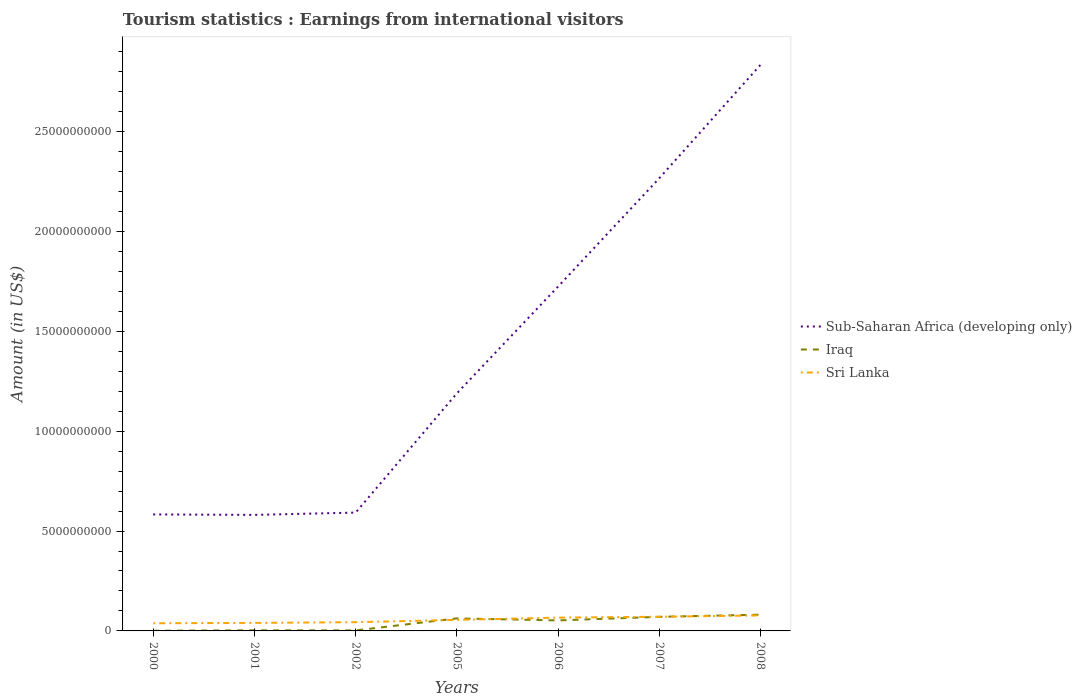Is the number of lines equal to the number of legend labels?
Your answer should be compact. Yes. Across all years, what is the maximum earnings from international visitors in Sri Lanka?
Your response must be concise. 3.83e+08. In which year was the earnings from international visitors in Sub-Saharan Africa (developing only) maximum?
Provide a short and direct response. 2001. What is the total earnings from international visitors in Sub-Saharan Africa (developing only) in the graph?
Ensure brevity in your answer.  -1.64e+1. What is the difference between the highest and the second highest earnings from international visitors in Sub-Saharan Africa (developing only)?
Make the answer very short. 2.25e+1. What is the difference between two consecutive major ticks on the Y-axis?
Your answer should be compact. 5.00e+09. Are the values on the major ticks of Y-axis written in scientific E-notation?
Provide a succinct answer. No. Does the graph contain grids?
Your answer should be compact. No. How many legend labels are there?
Your response must be concise. 3. How are the legend labels stacked?
Keep it short and to the point. Vertical. What is the title of the graph?
Give a very brief answer. Tourism statistics : Earnings from international visitors. Does "Bangladesh" appear as one of the legend labels in the graph?
Offer a terse response. No. What is the Amount (in US$) of Sub-Saharan Africa (developing only) in 2000?
Your answer should be very brief. 5.83e+09. What is the Amount (in US$) of Iraq in 2000?
Your answer should be very brief. 9.00e+06. What is the Amount (in US$) in Sri Lanka in 2000?
Make the answer very short. 3.83e+08. What is the Amount (in US$) of Sub-Saharan Africa (developing only) in 2001?
Make the answer very short. 5.81e+09. What is the Amount (in US$) of Iraq in 2001?
Your response must be concise. 3.10e+07. What is the Amount (in US$) of Sri Lanka in 2001?
Ensure brevity in your answer.  4.02e+08. What is the Amount (in US$) of Sub-Saharan Africa (developing only) in 2002?
Your answer should be very brief. 5.92e+09. What is the Amount (in US$) in Iraq in 2002?
Your answer should be compact. 2.60e+07. What is the Amount (in US$) in Sri Lanka in 2002?
Give a very brief answer. 4.38e+08. What is the Amount (in US$) in Sub-Saharan Africa (developing only) in 2005?
Provide a succinct answer. 1.19e+1. What is the Amount (in US$) in Iraq in 2005?
Give a very brief answer. 6.27e+08. What is the Amount (in US$) in Sri Lanka in 2005?
Your response must be concise. 5.52e+08. What is the Amount (in US$) in Sub-Saharan Africa (developing only) in 2006?
Give a very brief answer. 1.72e+1. What is the Amount (in US$) in Iraq in 2006?
Offer a terse response. 5.26e+08. What is the Amount (in US$) of Sri Lanka in 2006?
Keep it short and to the point. 6.66e+08. What is the Amount (in US$) of Sub-Saharan Africa (developing only) in 2007?
Your answer should be compact. 2.27e+1. What is the Amount (in US$) in Iraq in 2007?
Offer a very short reply. 7.05e+08. What is the Amount (in US$) of Sri Lanka in 2007?
Give a very brief answer. 7.09e+08. What is the Amount (in US$) of Sub-Saharan Africa (developing only) in 2008?
Give a very brief answer. 2.83e+1. What is the Amount (in US$) of Iraq in 2008?
Make the answer very short. 8.13e+08. What is the Amount (in US$) in Sri Lanka in 2008?
Your answer should be compact. 7.77e+08. Across all years, what is the maximum Amount (in US$) of Sub-Saharan Africa (developing only)?
Offer a very short reply. 2.83e+1. Across all years, what is the maximum Amount (in US$) in Iraq?
Your answer should be very brief. 8.13e+08. Across all years, what is the maximum Amount (in US$) of Sri Lanka?
Your response must be concise. 7.77e+08. Across all years, what is the minimum Amount (in US$) in Sub-Saharan Africa (developing only)?
Provide a short and direct response. 5.81e+09. Across all years, what is the minimum Amount (in US$) of Iraq?
Keep it short and to the point. 9.00e+06. Across all years, what is the minimum Amount (in US$) of Sri Lanka?
Keep it short and to the point. 3.83e+08. What is the total Amount (in US$) in Sub-Saharan Africa (developing only) in the graph?
Offer a very short reply. 9.77e+1. What is the total Amount (in US$) in Iraq in the graph?
Offer a terse response. 2.74e+09. What is the total Amount (in US$) of Sri Lanka in the graph?
Make the answer very short. 3.93e+09. What is the difference between the Amount (in US$) of Sub-Saharan Africa (developing only) in 2000 and that in 2001?
Your answer should be very brief. 2.30e+07. What is the difference between the Amount (in US$) of Iraq in 2000 and that in 2001?
Make the answer very short. -2.20e+07. What is the difference between the Amount (in US$) of Sri Lanka in 2000 and that in 2001?
Provide a succinct answer. -1.90e+07. What is the difference between the Amount (in US$) in Sub-Saharan Africa (developing only) in 2000 and that in 2002?
Make the answer very short. -9.17e+07. What is the difference between the Amount (in US$) in Iraq in 2000 and that in 2002?
Offer a very short reply. -1.70e+07. What is the difference between the Amount (in US$) in Sri Lanka in 2000 and that in 2002?
Provide a succinct answer. -5.50e+07. What is the difference between the Amount (in US$) of Sub-Saharan Africa (developing only) in 2000 and that in 2005?
Ensure brevity in your answer.  -6.06e+09. What is the difference between the Amount (in US$) in Iraq in 2000 and that in 2005?
Keep it short and to the point. -6.18e+08. What is the difference between the Amount (in US$) of Sri Lanka in 2000 and that in 2005?
Provide a succinct answer. -1.69e+08. What is the difference between the Amount (in US$) of Sub-Saharan Africa (developing only) in 2000 and that in 2006?
Keep it short and to the point. -1.14e+1. What is the difference between the Amount (in US$) in Iraq in 2000 and that in 2006?
Make the answer very short. -5.17e+08. What is the difference between the Amount (in US$) of Sri Lanka in 2000 and that in 2006?
Your response must be concise. -2.83e+08. What is the difference between the Amount (in US$) in Sub-Saharan Africa (developing only) in 2000 and that in 2007?
Your response must be concise. -1.68e+1. What is the difference between the Amount (in US$) of Iraq in 2000 and that in 2007?
Your response must be concise. -6.96e+08. What is the difference between the Amount (in US$) in Sri Lanka in 2000 and that in 2007?
Provide a succinct answer. -3.26e+08. What is the difference between the Amount (in US$) in Sub-Saharan Africa (developing only) in 2000 and that in 2008?
Offer a very short reply. -2.25e+1. What is the difference between the Amount (in US$) in Iraq in 2000 and that in 2008?
Provide a short and direct response. -8.04e+08. What is the difference between the Amount (in US$) in Sri Lanka in 2000 and that in 2008?
Your response must be concise. -3.94e+08. What is the difference between the Amount (in US$) in Sub-Saharan Africa (developing only) in 2001 and that in 2002?
Keep it short and to the point. -1.15e+08. What is the difference between the Amount (in US$) of Iraq in 2001 and that in 2002?
Give a very brief answer. 5.00e+06. What is the difference between the Amount (in US$) in Sri Lanka in 2001 and that in 2002?
Offer a terse response. -3.60e+07. What is the difference between the Amount (in US$) of Sub-Saharan Africa (developing only) in 2001 and that in 2005?
Offer a terse response. -6.08e+09. What is the difference between the Amount (in US$) of Iraq in 2001 and that in 2005?
Keep it short and to the point. -5.96e+08. What is the difference between the Amount (in US$) of Sri Lanka in 2001 and that in 2005?
Your answer should be compact. -1.50e+08. What is the difference between the Amount (in US$) in Sub-Saharan Africa (developing only) in 2001 and that in 2006?
Provide a succinct answer. -1.14e+1. What is the difference between the Amount (in US$) in Iraq in 2001 and that in 2006?
Your response must be concise. -4.95e+08. What is the difference between the Amount (in US$) in Sri Lanka in 2001 and that in 2006?
Keep it short and to the point. -2.64e+08. What is the difference between the Amount (in US$) of Sub-Saharan Africa (developing only) in 2001 and that in 2007?
Provide a succinct answer. -1.68e+1. What is the difference between the Amount (in US$) in Iraq in 2001 and that in 2007?
Your answer should be very brief. -6.74e+08. What is the difference between the Amount (in US$) in Sri Lanka in 2001 and that in 2007?
Your answer should be compact. -3.07e+08. What is the difference between the Amount (in US$) in Sub-Saharan Africa (developing only) in 2001 and that in 2008?
Offer a very short reply. -2.25e+1. What is the difference between the Amount (in US$) in Iraq in 2001 and that in 2008?
Offer a terse response. -7.82e+08. What is the difference between the Amount (in US$) of Sri Lanka in 2001 and that in 2008?
Your answer should be compact. -3.75e+08. What is the difference between the Amount (in US$) in Sub-Saharan Africa (developing only) in 2002 and that in 2005?
Your answer should be compact. -5.97e+09. What is the difference between the Amount (in US$) in Iraq in 2002 and that in 2005?
Offer a very short reply. -6.01e+08. What is the difference between the Amount (in US$) of Sri Lanka in 2002 and that in 2005?
Provide a short and direct response. -1.14e+08. What is the difference between the Amount (in US$) of Sub-Saharan Africa (developing only) in 2002 and that in 2006?
Offer a terse response. -1.13e+1. What is the difference between the Amount (in US$) of Iraq in 2002 and that in 2006?
Give a very brief answer. -5.00e+08. What is the difference between the Amount (in US$) of Sri Lanka in 2002 and that in 2006?
Your response must be concise. -2.28e+08. What is the difference between the Amount (in US$) of Sub-Saharan Africa (developing only) in 2002 and that in 2007?
Provide a succinct answer. -1.67e+1. What is the difference between the Amount (in US$) of Iraq in 2002 and that in 2007?
Make the answer very short. -6.79e+08. What is the difference between the Amount (in US$) in Sri Lanka in 2002 and that in 2007?
Your answer should be compact. -2.71e+08. What is the difference between the Amount (in US$) of Sub-Saharan Africa (developing only) in 2002 and that in 2008?
Your answer should be compact. -2.24e+1. What is the difference between the Amount (in US$) in Iraq in 2002 and that in 2008?
Your answer should be very brief. -7.87e+08. What is the difference between the Amount (in US$) of Sri Lanka in 2002 and that in 2008?
Make the answer very short. -3.39e+08. What is the difference between the Amount (in US$) in Sub-Saharan Africa (developing only) in 2005 and that in 2006?
Your answer should be very brief. -5.34e+09. What is the difference between the Amount (in US$) of Iraq in 2005 and that in 2006?
Offer a terse response. 1.01e+08. What is the difference between the Amount (in US$) in Sri Lanka in 2005 and that in 2006?
Your response must be concise. -1.14e+08. What is the difference between the Amount (in US$) in Sub-Saharan Africa (developing only) in 2005 and that in 2007?
Offer a terse response. -1.08e+1. What is the difference between the Amount (in US$) in Iraq in 2005 and that in 2007?
Give a very brief answer. -7.80e+07. What is the difference between the Amount (in US$) of Sri Lanka in 2005 and that in 2007?
Your answer should be compact. -1.57e+08. What is the difference between the Amount (in US$) of Sub-Saharan Africa (developing only) in 2005 and that in 2008?
Offer a terse response. -1.64e+1. What is the difference between the Amount (in US$) in Iraq in 2005 and that in 2008?
Provide a succinct answer. -1.86e+08. What is the difference between the Amount (in US$) in Sri Lanka in 2005 and that in 2008?
Your answer should be very brief. -2.25e+08. What is the difference between the Amount (in US$) in Sub-Saharan Africa (developing only) in 2006 and that in 2007?
Offer a terse response. -5.42e+09. What is the difference between the Amount (in US$) of Iraq in 2006 and that in 2007?
Give a very brief answer. -1.79e+08. What is the difference between the Amount (in US$) of Sri Lanka in 2006 and that in 2007?
Give a very brief answer. -4.30e+07. What is the difference between the Amount (in US$) of Sub-Saharan Africa (developing only) in 2006 and that in 2008?
Offer a very short reply. -1.11e+1. What is the difference between the Amount (in US$) of Iraq in 2006 and that in 2008?
Provide a short and direct response. -2.87e+08. What is the difference between the Amount (in US$) of Sri Lanka in 2006 and that in 2008?
Keep it short and to the point. -1.11e+08. What is the difference between the Amount (in US$) in Sub-Saharan Africa (developing only) in 2007 and that in 2008?
Offer a very short reply. -5.68e+09. What is the difference between the Amount (in US$) of Iraq in 2007 and that in 2008?
Make the answer very short. -1.08e+08. What is the difference between the Amount (in US$) of Sri Lanka in 2007 and that in 2008?
Provide a succinct answer. -6.80e+07. What is the difference between the Amount (in US$) of Sub-Saharan Africa (developing only) in 2000 and the Amount (in US$) of Iraq in 2001?
Give a very brief answer. 5.80e+09. What is the difference between the Amount (in US$) in Sub-Saharan Africa (developing only) in 2000 and the Amount (in US$) in Sri Lanka in 2001?
Keep it short and to the point. 5.43e+09. What is the difference between the Amount (in US$) in Iraq in 2000 and the Amount (in US$) in Sri Lanka in 2001?
Give a very brief answer. -3.93e+08. What is the difference between the Amount (in US$) of Sub-Saharan Africa (developing only) in 2000 and the Amount (in US$) of Iraq in 2002?
Offer a very short reply. 5.81e+09. What is the difference between the Amount (in US$) in Sub-Saharan Africa (developing only) in 2000 and the Amount (in US$) in Sri Lanka in 2002?
Your answer should be very brief. 5.39e+09. What is the difference between the Amount (in US$) of Iraq in 2000 and the Amount (in US$) of Sri Lanka in 2002?
Ensure brevity in your answer.  -4.29e+08. What is the difference between the Amount (in US$) of Sub-Saharan Africa (developing only) in 2000 and the Amount (in US$) of Iraq in 2005?
Provide a short and direct response. 5.20e+09. What is the difference between the Amount (in US$) of Sub-Saharan Africa (developing only) in 2000 and the Amount (in US$) of Sri Lanka in 2005?
Your response must be concise. 5.28e+09. What is the difference between the Amount (in US$) of Iraq in 2000 and the Amount (in US$) of Sri Lanka in 2005?
Keep it short and to the point. -5.43e+08. What is the difference between the Amount (in US$) of Sub-Saharan Africa (developing only) in 2000 and the Amount (in US$) of Iraq in 2006?
Make the answer very short. 5.31e+09. What is the difference between the Amount (in US$) of Sub-Saharan Africa (developing only) in 2000 and the Amount (in US$) of Sri Lanka in 2006?
Your answer should be compact. 5.17e+09. What is the difference between the Amount (in US$) of Iraq in 2000 and the Amount (in US$) of Sri Lanka in 2006?
Offer a terse response. -6.57e+08. What is the difference between the Amount (in US$) of Sub-Saharan Africa (developing only) in 2000 and the Amount (in US$) of Iraq in 2007?
Offer a terse response. 5.13e+09. What is the difference between the Amount (in US$) in Sub-Saharan Africa (developing only) in 2000 and the Amount (in US$) in Sri Lanka in 2007?
Ensure brevity in your answer.  5.12e+09. What is the difference between the Amount (in US$) of Iraq in 2000 and the Amount (in US$) of Sri Lanka in 2007?
Make the answer very short. -7.00e+08. What is the difference between the Amount (in US$) of Sub-Saharan Africa (developing only) in 2000 and the Amount (in US$) of Iraq in 2008?
Keep it short and to the point. 5.02e+09. What is the difference between the Amount (in US$) of Sub-Saharan Africa (developing only) in 2000 and the Amount (in US$) of Sri Lanka in 2008?
Your answer should be compact. 5.05e+09. What is the difference between the Amount (in US$) in Iraq in 2000 and the Amount (in US$) in Sri Lanka in 2008?
Provide a succinct answer. -7.68e+08. What is the difference between the Amount (in US$) in Sub-Saharan Africa (developing only) in 2001 and the Amount (in US$) in Iraq in 2002?
Provide a succinct answer. 5.78e+09. What is the difference between the Amount (in US$) in Sub-Saharan Africa (developing only) in 2001 and the Amount (in US$) in Sri Lanka in 2002?
Offer a very short reply. 5.37e+09. What is the difference between the Amount (in US$) of Iraq in 2001 and the Amount (in US$) of Sri Lanka in 2002?
Ensure brevity in your answer.  -4.07e+08. What is the difference between the Amount (in US$) of Sub-Saharan Africa (developing only) in 2001 and the Amount (in US$) of Iraq in 2005?
Your answer should be very brief. 5.18e+09. What is the difference between the Amount (in US$) of Sub-Saharan Africa (developing only) in 2001 and the Amount (in US$) of Sri Lanka in 2005?
Keep it short and to the point. 5.26e+09. What is the difference between the Amount (in US$) of Iraq in 2001 and the Amount (in US$) of Sri Lanka in 2005?
Your answer should be very brief. -5.21e+08. What is the difference between the Amount (in US$) of Sub-Saharan Africa (developing only) in 2001 and the Amount (in US$) of Iraq in 2006?
Offer a terse response. 5.28e+09. What is the difference between the Amount (in US$) of Sub-Saharan Africa (developing only) in 2001 and the Amount (in US$) of Sri Lanka in 2006?
Give a very brief answer. 5.14e+09. What is the difference between the Amount (in US$) of Iraq in 2001 and the Amount (in US$) of Sri Lanka in 2006?
Offer a terse response. -6.35e+08. What is the difference between the Amount (in US$) of Sub-Saharan Africa (developing only) in 2001 and the Amount (in US$) of Iraq in 2007?
Give a very brief answer. 5.10e+09. What is the difference between the Amount (in US$) of Sub-Saharan Africa (developing only) in 2001 and the Amount (in US$) of Sri Lanka in 2007?
Ensure brevity in your answer.  5.10e+09. What is the difference between the Amount (in US$) of Iraq in 2001 and the Amount (in US$) of Sri Lanka in 2007?
Give a very brief answer. -6.78e+08. What is the difference between the Amount (in US$) in Sub-Saharan Africa (developing only) in 2001 and the Amount (in US$) in Iraq in 2008?
Your response must be concise. 5.00e+09. What is the difference between the Amount (in US$) of Sub-Saharan Africa (developing only) in 2001 and the Amount (in US$) of Sri Lanka in 2008?
Your answer should be very brief. 5.03e+09. What is the difference between the Amount (in US$) of Iraq in 2001 and the Amount (in US$) of Sri Lanka in 2008?
Your answer should be compact. -7.46e+08. What is the difference between the Amount (in US$) in Sub-Saharan Africa (developing only) in 2002 and the Amount (in US$) in Iraq in 2005?
Your response must be concise. 5.30e+09. What is the difference between the Amount (in US$) of Sub-Saharan Africa (developing only) in 2002 and the Amount (in US$) of Sri Lanka in 2005?
Keep it short and to the point. 5.37e+09. What is the difference between the Amount (in US$) in Iraq in 2002 and the Amount (in US$) in Sri Lanka in 2005?
Your answer should be very brief. -5.26e+08. What is the difference between the Amount (in US$) of Sub-Saharan Africa (developing only) in 2002 and the Amount (in US$) of Iraq in 2006?
Ensure brevity in your answer.  5.40e+09. What is the difference between the Amount (in US$) in Sub-Saharan Africa (developing only) in 2002 and the Amount (in US$) in Sri Lanka in 2006?
Your answer should be compact. 5.26e+09. What is the difference between the Amount (in US$) in Iraq in 2002 and the Amount (in US$) in Sri Lanka in 2006?
Ensure brevity in your answer.  -6.40e+08. What is the difference between the Amount (in US$) of Sub-Saharan Africa (developing only) in 2002 and the Amount (in US$) of Iraq in 2007?
Make the answer very short. 5.22e+09. What is the difference between the Amount (in US$) in Sub-Saharan Africa (developing only) in 2002 and the Amount (in US$) in Sri Lanka in 2007?
Offer a terse response. 5.21e+09. What is the difference between the Amount (in US$) in Iraq in 2002 and the Amount (in US$) in Sri Lanka in 2007?
Provide a succinct answer. -6.83e+08. What is the difference between the Amount (in US$) of Sub-Saharan Africa (developing only) in 2002 and the Amount (in US$) of Iraq in 2008?
Give a very brief answer. 5.11e+09. What is the difference between the Amount (in US$) in Sub-Saharan Africa (developing only) in 2002 and the Amount (in US$) in Sri Lanka in 2008?
Provide a short and direct response. 5.15e+09. What is the difference between the Amount (in US$) in Iraq in 2002 and the Amount (in US$) in Sri Lanka in 2008?
Your answer should be compact. -7.51e+08. What is the difference between the Amount (in US$) in Sub-Saharan Africa (developing only) in 2005 and the Amount (in US$) in Iraq in 2006?
Provide a short and direct response. 1.14e+1. What is the difference between the Amount (in US$) of Sub-Saharan Africa (developing only) in 2005 and the Amount (in US$) of Sri Lanka in 2006?
Keep it short and to the point. 1.12e+1. What is the difference between the Amount (in US$) of Iraq in 2005 and the Amount (in US$) of Sri Lanka in 2006?
Provide a succinct answer. -3.90e+07. What is the difference between the Amount (in US$) in Sub-Saharan Africa (developing only) in 2005 and the Amount (in US$) in Iraq in 2007?
Keep it short and to the point. 1.12e+1. What is the difference between the Amount (in US$) in Sub-Saharan Africa (developing only) in 2005 and the Amount (in US$) in Sri Lanka in 2007?
Your answer should be very brief. 1.12e+1. What is the difference between the Amount (in US$) in Iraq in 2005 and the Amount (in US$) in Sri Lanka in 2007?
Give a very brief answer. -8.20e+07. What is the difference between the Amount (in US$) of Sub-Saharan Africa (developing only) in 2005 and the Amount (in US$) of Iraq in 2008?
Offer a terse response. 1.11e+1. What is the difference between the Amount (in US$) in Sub-Saharan Africa (developing only) in 2005 and the Amount (in US$) in Sri Lanka in 2008?
Keep it short and to the point. 1.11e+1. What is the difference between the Amount (in US$) of Iraq in 2005 and the Amount (in US$) of Sri Lanka in 2008?
Your answer should be very brief. -1.50e+08. What is the difference between the Amount (in US$) in Sub-Saharan Africa (developing only) in 2006 and the Amount (in US$) in Iraq in 2007?
Offer a terse response. 1.65e+1. What is the difference between the Amount (in US$) of Sub-Saharan Africa (developing only) in 2006 and the Amount (in US$) of Sri Lanka in 2007?
Offer a very short reply. 1.65e+1. What is the difference between the Amount (in US$) of Iraq in 2006 and the Amount (in US$) of Sri Lanka in 2007?
Keep it short and to the point. -1.83e+08. What is the difference between the Amount (in US$) of Sub-Saharan Africa (developing only) in 2006 and the Amount (in US$) of Iraq in 2008?
Offer a very short reply. 1.64e+1. What is the difference between the Amount (in US$) of Sub-Saharan Africa (developing only) in 2006 and the Amount (in US$) of Sri Lanka in 2008?
Your answer should be compact. 1.65e+1. What is the difference between the Amount (in US$) of Iraq in 2006 and the Amount (in US$) of Sri Lanka in 2008?
Ensure brevity in your answer.  -2.51e+08. What is the difference between the Amount (in US$) of Sub-Saharan Africa (developing only) in 2007 and the Amount (in US$) of Iraq in 2008?
Your response must be concise. 2.18e+1. What is the difference between the Amount (in US$) in Sub-Saharan Africa (developing only) in 2007 and the Amount (in US$) in Sri Lanka in 2008?
Your response must be concise. 2.19e+1. What is the difference between the Amount (in US$) in Iraq in 2007 and the Amount (in US$) in Sri Lanka in 2008?
Your answer should be compact. -7.20e+07. What is the average Amount (in US$) in Sub-Saharan Africa (developing only) per year?
Your answer should be very brief. 1.40e+1. What is the average Amount (in US$) in Iraq per year?
Keep it short and to the point. 3.91e+08. What is the average Amount (in US$) in Sri Lanka per year?
Your answer should be very brief. 5.61e+08. In the year 2000, what is the difference between the Amount (in US$) of Sub-Saharan Africa (developing only) and Amount (in US$) of Iraq?
Make the answer very short. 5.82e+09. In the year 2000, what is the difference between the Amount (in US$) in Sub-Saharan Africa (developing only) and Amount (in US$) in Sri Lanka?
Make the answer very short. 5.45e+09. In the year 2000, what is the difference between the Amount (in US$) in Iraq and Amount (in US$) in Sri Lanka?
Keep it short and to the point. -3.74e+08. In the year 2001, what is the difference between the Amount (in US$) of Sub-Saharan Africa (developing only) and Amount (in US$) of Iraq?
Your response must be concise. 5.78e+09. In the year 2001, what is the difference between the Amount (in US$) of Sub-Saharan Africa (developing only) and Amount (in US$) of Sri Lanka?
Your answer should be compact. 5.41e+09. In the year 2001, what is the difference between the Amount (in US$) of Iraq and Amount (in US$) of Sri Lanka?
Make the answer very short. -3.71e+08. In the year 2002, what is the difference between the Amount (in US$) of Sub-Saharan Africa (developing only) and Amount (in US$) of Iraq?
Your answer should be very brief. 5.90e+09. In the year 2002, what is the difference between the Amount (in US$) of Sub-Saharan Africa (developing only) and Amount (in US$) of Sri Lanka?
Your answer should be very brief. 5.48e+09. In the year 2002, what is the difference between the Amount (in US$) in Iraq and Amount (in US$) in Sri Lanka?
Provide a succinct answer. -4.12e+08. In the year 2005, what is the difference between the Amount (in US$) of Sub-Saharan Africa (developing only) and Amount (in US$) of Iraq?
Give a very brief answer. 1.13e+1. In the year 2005, what is the difference between the Amount (in US$) of Sub-Saharan Africa (developing only) and Amount (in US$) of Sri Lanka?
Give a very brief answer. 1.13e+1. In the year 2005, what is the difference between the Amount (in US$) in Iraq and Amount (in US$) in Sri Lanka?
Ensure brevity in your answer.  7.50e+07. In the year 2006, what is the difference between the Amount (in US$) of Sub-Saharan Africa (developing only) and Amount (in US$) of Iraq?
Keep it short and to the point. 1.67e+1. In the year 2006, what is the difference between the Amount (in US$) in Sub-Saharan Africa (developing only) and Amount (in US$) in Sri Lanka?
Provide a short and direct response. 1.66e+1. In the year 2006, what is the difference between the Amount (in US$) in Iraq and Amount (in US$) in Sri Lanka?
Offer a terse response. -1.40e+08. In the year 2007, what is the difference between the Amount (in US$) of Sub-Saharan Africa (developing only) and Amount (in US$) of Iraq?
Your answer should be very brief. 2.20e+1. In the year 2007, what is the difference between the Amount (in US$) in Sub-Saharan Africa (developing only) and Amount (in US$) in Sri Lanka?
Ensure brevity in your answer.  2.19e+1. In the year 2007, what is the difference between the Amount (in US$) of Iraq and Amount (in US$) of Sri Lanka?
Make the answer very short. -4.00e+06. In the year 2008, what is the difference between the Amount (in US$) of Sub-Saharan Africa (developing only) and Amount (in US$) of Iraq?
Your answer should be very brief. 2.75e+1. In the year 2008, what is the difference between the Amount (in US$) in Sub-Saharan Africa (developing only) and Amount (in US$) in Sri Lanka?
Your answer should be very brief. 2.76e+1. In the year 2008, what is the difference between the Amount (in US$) of Iraq and Amount (in US$) of Sri Lanka?
Keep it short and to the point. 3.60e+07. What is the ratio of the Amount (in US$) in Sub-Saharan Africa (developing only) in 2000 to that in 2001?
Make the answer very short. 1. What is the ratio of the Amount (in US$) in Iraq in 2000 to that in 2001?
Offer a terse response. 0.29. What is the ratio of the Amount (in US$) of Sri Lanka in 2000 to that in 2001?
Provide a succinct answer. 0.95. What is the ratio of the Amount (in US$) of Sub-Saharan Africa (developing only) in 2000 to that in 2002?
Your answer should be compact. 0.98. What is the ratio of the Amount (in US$) of Iraq in 2000 to that in 2002?
Give a very brief answer. 0.35. What is the ratio of the Amount (in US$) in Sri Lanka in 2000 to that in 2002?
Provide a short and direct response. 0.87. What is the ratio of the Amount (in US$) of Sub-Saharan Africa (developing only) in 2000 to that in 2005?
Give a very brief answer. 0.49. What is the ratio of the Amount (in US$) in Iraq in 2000 to that in 2005?
Offer a terse response. 0.01. What is the ratio of the Amount (in US$) in Sri Lanka in 2000 to that in 2005?
Make the answer very short. 0.69. What is the ratio of the Amount (in US$) in Sub-Saharan Africa (developing only) in 2000 to that in 2006?
Your answer should be very brief. 0.34. What is the ratio of the Amount (in US$) in Iraq in 2000 to that in 2006?
Your answer should be compact. 0.02. What is the ratio of the Amount (in US$) of Sri Lanka in 2000 to that in 2006?
Provide a short and direct response. 0.58. What is the ratio of the Amount (in US$) of Sub-Saharan Africa (developing only) in 2000 to that in 2007?
Ensure brevity in your answer.  0.26. What is the ratio of the Amount (in US$) of Iraq in 2000 to that in 2007?
Keep it short and to the point. 0.01. What is the ratio of the Amount (in US$) in Sri Lanka in 2000 to that in 2007?
Your answer should be very brief. 0.54. What is the ratio of the Amount (in US$) of Sub-Saharan Africa (developing only) in 2000 to that in 2008?
Your answer should be compact. 0.21. What is the ratio of the Amount (in US$) of Iraq in 2000 to that in 2008?
Keep it short and to the point. 0.01. What is the ratio of the Amount (in US$) of Sri Lanka in 2000 to that in 2008?
Give a very brief answer. 0.49. What is the ratio of the Amount (in US$) of Sub-Saharan Africa (developing only) in 2001 to that in 2002?
Keep it short and to the point. 0.98. What is the ratio of the Amount (in US$) in Iraq in 2001 to that in 2002?
Provide a succinct answer. 1.19. What is the ratio of the Amount (in US$) in Sri Lanka in 2001 to that in 2002?
Offer a terse response. 0.92. What is the ratio of the Amount (in US$) in Sub-Saharan Africa (developing only) in 2001 to that in 2005?
Your response must be concise. 0.49. What is the ratio of the Amount (in US$) in Iraq in 2001 to that in 2005?
Your answer should be very brief. 0.05. What is the ratio of the Amount (in US$) in Sri Lanka in 2001 to that in 2005?
Give a very brief answer. 0.73. What is the ratio of the Amount (in US$) in Sub-Saharan Africa (developing only) in 2001 to that in 2006?
Make the answer very short. 0.34. What is the ratio of the Amount (in US$) of Iraq in 2001 to that in 2006?
Offer a very short reply. 0.06. What is the ratio of the Amount (in US$) in Sri Lanka in 2001 to that in 2006?
Your answer should be very brief. 0.6. What is the ratio of the Amount (in US$) in Sub-Saharan Africa (developing only) in 2001 to that in 2007?
Offer a terse response. 0.26. What is the ratio of the Amount (in US$) in Iraq in 2001 to that in 2007?
Your answer should be very brief. 0.04. What is the ratio of the Amount (in US$) in Sri Lanka in 2001 to that in 2007?
Ensure brevity in your answer.  0.57. What is the ratio of the Amount (in US$) of Sub-Saharan Africa (developing only) in 2001 to that in 2008?
Ensure brevity in your answer.  0.2. What is the ratio of the Amount (in US$) of Iraq in 2001 to that in 2008?
Provide a succinct answer. 0.04. What is the ratio of the Amount (in US$) in Sri Lanka in 2001 to that in 2008?
Provide a succinct answer. 0.52. What is the ratio of the Amount (in US$) of Sub-Saharan Africa (developing only) in 2002 to that in 2005?
Give a very brief answer. 0.5. What is the ratio of the Amount (in US$) in Iraq in 2002 to that in 2005?
Ensure brevity in your answer.  0.04. What is the ratio of the Amount (in US$) in Sri Lanka in 2002 to that in 2005?
Keep it short and to the point. 0.79. What is the ratio of the Amount (in US$) in Sub-Saharan Africa (developing only) in 2002 to that in 2006?
Your answer should be compact. 0.34. What is the ratio of the Amount (in US$) of Iraq in 2002 to that in 2006?
Keep it short and to the point. 0.05. What is the ratio of the Amount (in US$) in Sri Lanka in 2002 to that in 2006?
Your response must be concise. 0.66. What is the ratio of the Amount (in US$) of Sub-Saharan Africa (developing only) in 2002 to that in 2007?
Make the answer very short. 0.26. What is the ratio of the Amount (in US$) of Iraq in 2002 to that in 2007?
Your answer should be compact. 0.04. What is the ratio of the Amount (in US$) in Sri Lanka in 2002 to that in 2007?
Ensure brevity in your answer.  0.62. What is the ratio of the Amount (in US$) in Sub-Saharan Africa (developing only) in 2002 to that in 2008?
Offer a very short reply. 0.21. What is the ratio of the Amount (in US$) in Iraq in 2002 to that in 2008?
Give a very brief answer. 0.03. What is the ratio of the Amount (in US$) in Sri Lanka in 2002 to that in 2008?
Your answer should be very brief. 0.56. What is the ratio of the Amount (in US$) of Sub-Saharan Africa (developing only) in 2005 to that in 2006?
Offer a terse response. 0.69. What is the ratio of the Amount (in US$) in Iraq in 2005 to that in 2006?
Your answer should be very brief. 1.19. What is the ratio of the Amount (in US$) in Sri Lanka in 2005 to that in 2006?
Your answer should be compact. 0.83. What is the ratio of the Amount (in US$) of Sub-Saharan Africa (developing only) in 2005 to that in 2007?
Offer a very short reply. 0.52. What is the ratio of the Amount (in US$) in Iraq in 2005 to that in 2007?
Ensure brevity in your answer.  0.89. What is the ratio of the Amount (in US$) of Sri Lanka in 2005 to that in 2007?
Your answer should be very brief. 0.78. What is the ratio of the Amount (in US$) of Sub-Saharan Africa (developing only) in 2005 to that in 2008?
Ensure brevity in your answer.  0.42. What is the ratio of the Amount (in US$) in Iraq in 2005 to that in 2008?
Provide a short and direct response. 0.77. What is the ratio of the Amount (in US$) in Sri Lanka in 2005 to that in 2008?
Give a very brief answer. 0.71. What is the ratio of the Amount (in US$) of Sub-Saharan Africa (developing only) in 2006 to that in 2007?
Offer a terse response. 0.76. What is the ratio of the Amount (in US$) in Iraq in 2006 to that in 2007?
Make the answer very short. 0.75. What is the ratio of the Amount (in US$) in Sri Lanka in 2006 to that in 2007?
Keep it short and to the point. 0.94. What is the ratio of the Amount (in US$) of Sub-Saharan Africa (developing only) in 2006 to that in 2008?
Offer a very short reply. 0.61. What is the ratio of the Amount (in US$) of Iraq in 2006 to that in 2008?
Keep it short and to the point. 0.65. What is the ratio of the Amount (in US$) in Sri Lanka in 2006 to that in 2008?
Your response must be concise. 0.86. What is the ratio of the Amount (in US$) in Sub-Saharan Africa (developing only) in 2007 to that in 2008?
Your response must be concise. 0.8. What is the ratio of the Amount (in US$) of Iraq in 2007 to that in 2008?
Offer a terse response. 0.87. What is the ratio of the Amount (in US$) in Sri Lanka in 2007 to that in 2008?
Make the answer very short. 0.91. What is the difference between the highest and the second highest Amount (in US$) of Sub-Saharan Africa (developing only)?
Keep it short and to the point. 5.68e+09. What is the difference between the highest and the second highest Amount (in US$) in Iraq?
Offer a very short reply. 1.08e+08. What is the difference between the highest and the second highest Amount (in US$) of Sri Lanka?
Provide a succinct answer. 6.80e+07. What is the difference between the highest and the lowest Amount (in US$) in Sub-Saharan Africa (developing only)?
Give a very brief answer. 2.25e+1. What is the difference between the highest and the lowest Amount (in US$) in Iraq?
Give a very brief answer. 8.04e+08. What is the difference between the highest and the lowest Amount (in US$) of Sri Lanka?
Your response must be concise. 3.94e+08. 